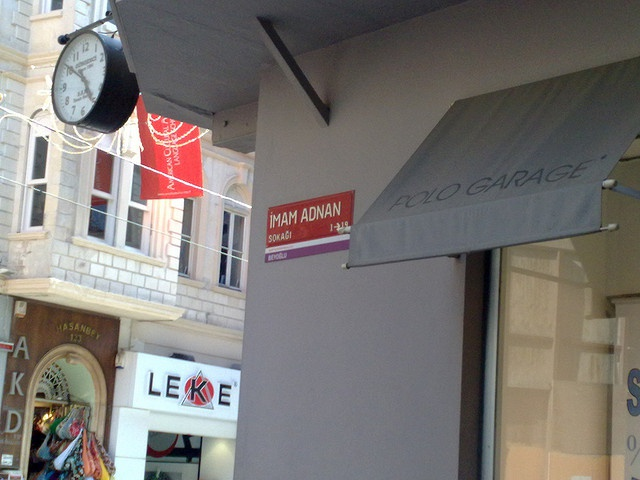Describe the objects in this image and their specific colors. I can see clock in lightblue, black, darkgray, and gray tones, handbag in lightblue, gray, and black tones, handbag in lightblue, black, gray, blue, and navy tones, handbag in lightblue and gray tones, and handbag in lightblue, gray, black, and teal tones in this image. 